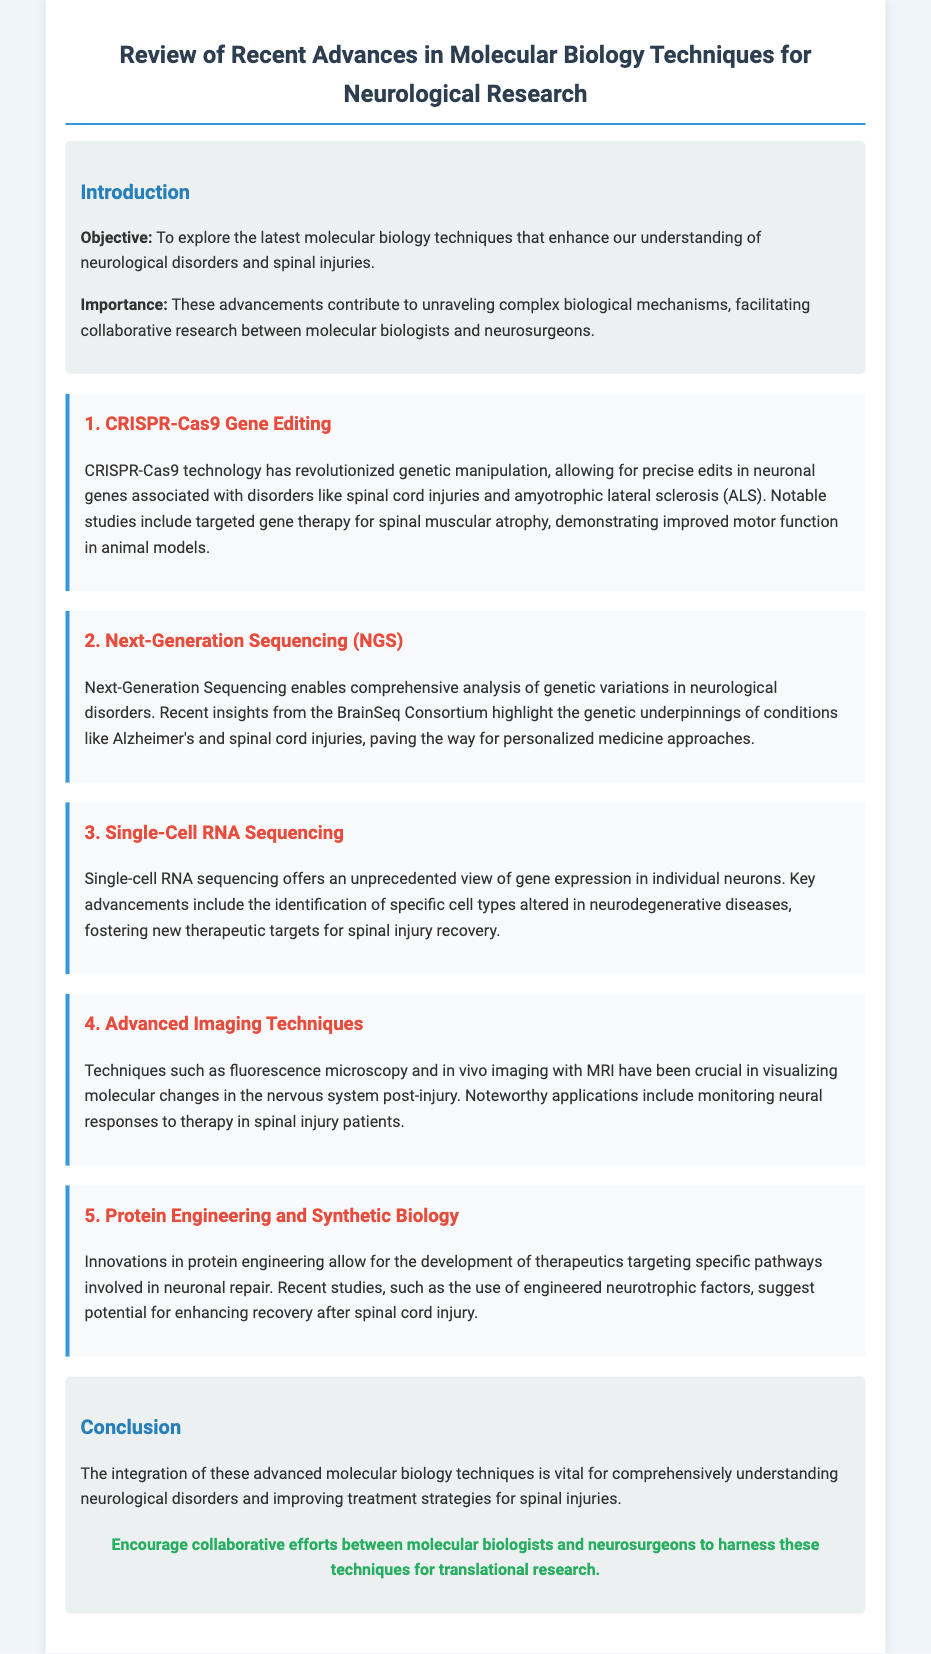What is the main objective of the document? The objective is to explore the latest molecular biology techniques that enhance our understanding of neurological disorders and spinal injuries.
Answer: To explore the latest molecular biology techniques that enhance our understanding of neurological disorders and spinal injuries Which technology allows for precise edits in neuronal genes? The document mentions CRISPR-Cas9 technology as a means for precise edits in neuronal genes.
Answer: CRISPR-Cas9 What has Next-Generation Sequencing enabled in neurological research? Next-Generation Sequencing enables comprehensive analysis of genetic variations in neurological disorders.
Answer: Comprehensive analysis of genetic variations What specific advancements does Single-Cell RNA Sequencing provide? The key advancements include the identification of specific cell types altered in neurodegenerative diseases.
Answer: Identification of specific cell types altered in neurodegenerative diseases Which imaging technique is mentioned for visualizing molecular changes post-injury? Fluorescence microscopy and in vivo imaging with MRI are mentioned for visualizing molecular changes.
Answer: Fluorescence microscopy and in vivo imaging with MRI What recent studies suggest potential for enhancing recovery after spinal cord injury? Recent studies involve the use of engineered neurotrophic factors indicating potential for enhancing recovery.
Answer: Use of engineered neurotrophic factors What theme do the advanced techniques discussed in the document share? The advanced techniques share a theme of improving understanding and treatment of neurological disorders.
Answer: Improving understanding and treatment of neurological disorders What is the call to action stated in the conclusion? The call to action encourages collaborative efforts between molecular biologists and neurosurgeons.
Answer: Encourage collaborative efforts between molecular biologists and neurosurgeons 